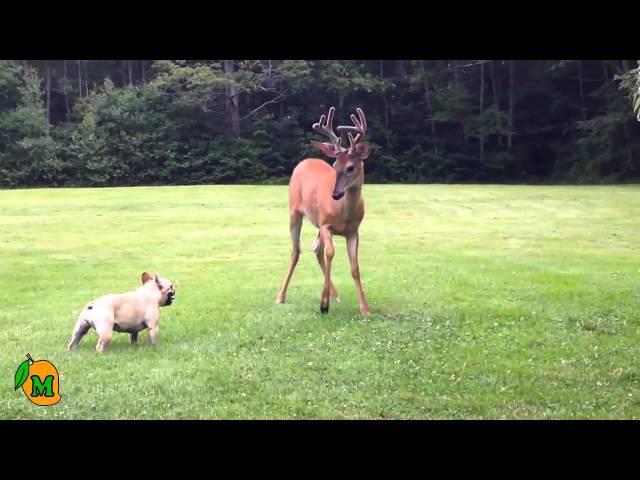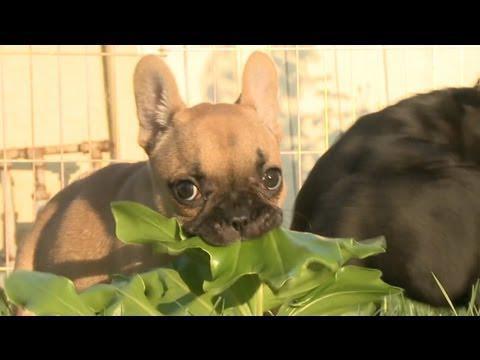The first image is the image on the left, the second image is the image on the right. Considering the images on both sides, is "An image shows a tennis ball in front of one french bulldog, but not in contact with it." valid? Answer yes or no. No. The first image is the image on the left, the second image is the image on the right. Given the left and right images, does the statement "The left image includes a dog playing with a tennis ball." hold true? Answer yes or no. No. 